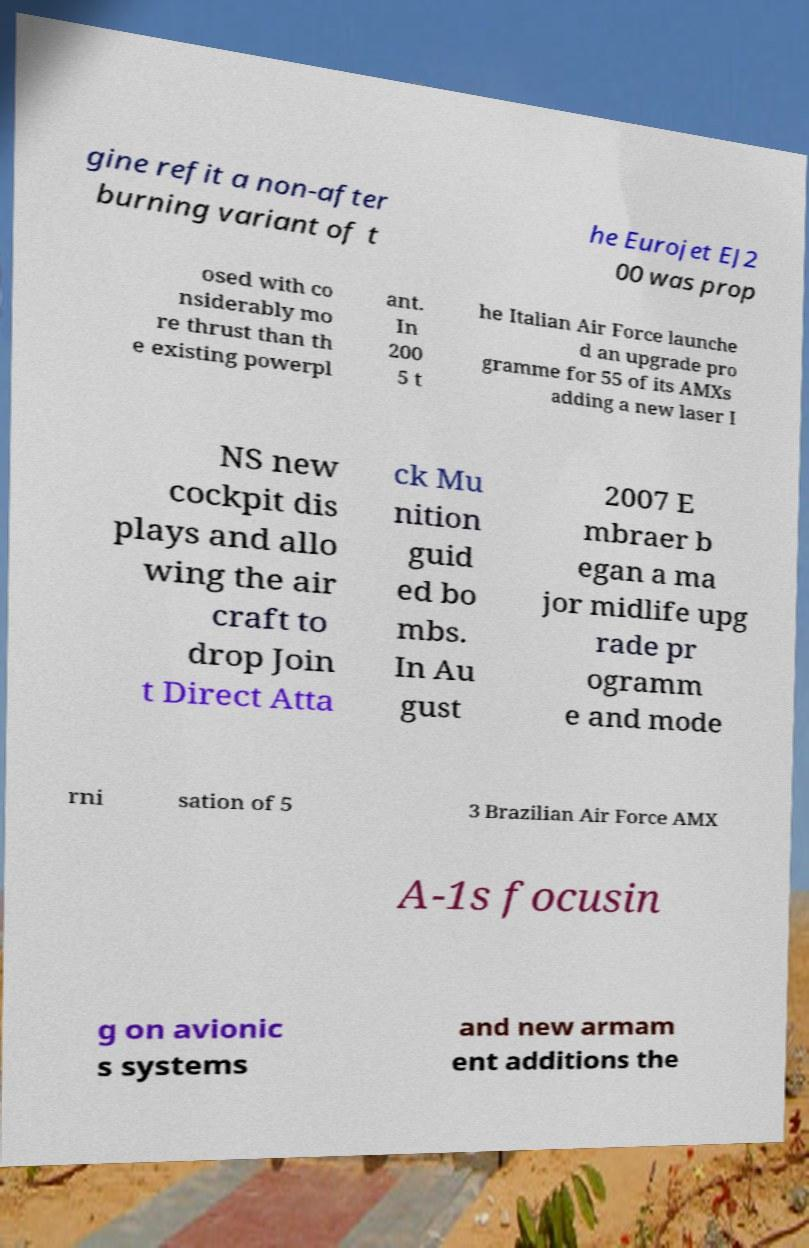For documentation purposes, I need the text within this image transcribed. Could you provide that? gine refit a non-after burning variant of t he Eurojet EJ2 00 was prop osed with co nsiderably mo re thrust than th e existing powerpl ant. In 200 5 t he Italian Air Force launche d an upgrade pro gramme for 55 of its AMXs adding a new laser I NS new cockpit dis plays and allo wing the air craft to drop Join t Direct Atta ck Mu nition guid ed bo mbs. In Au gust 2007 E mbraer b egan a ma jor midlife upg rade pr ogramm e and mode rni sation of 5 3 Brazilian Air Force AMX A-1s focusin g on avionic s systems and new armam ent additions the 